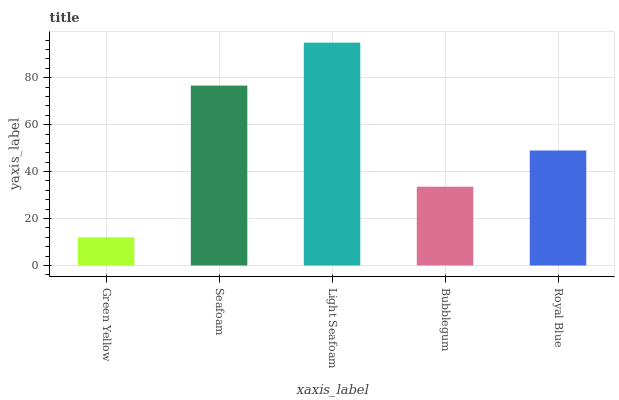Is Green Yellow the minimum?
Answer yes or no. Yes. Is Light Seafoam the maximum?
Answer yes or no. Yes. Is Seafoam the minimum?
Answer yes or no. No. Is Seafoam the maximum?
Answer yes or no. No. Is Seafoam greater than Green Yellow?
Answer yes or no. Yes. Is Green Yellow less than Seafoam?
Answer yes or no. Yes. Is Green Yellow greater than Seafoam?
Answer yes or no. No. Is Seafoam less than Green Yellow?
Answer yes or no. No. Is Royal Blue the high median?
Answer yes or no. Yes. Is Royal Blue the low median?
Answer yes or no. Yes. Is Light Seafoam the high median?
Answer yes or no. No. Is Seafoam the low median?
Answer yes or no. No. 